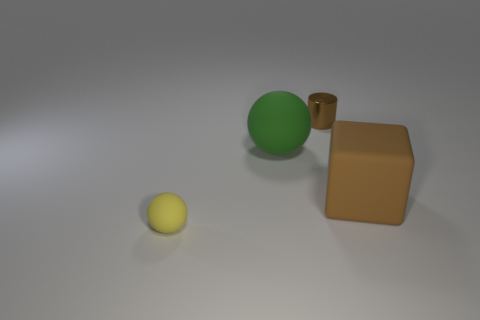Add 4 tiny purple things. How many objects exist? 8 Subtract all cubes. How many objects are left? 3 Subtract all brown shiny things. Subtract all big things. How many objects are left? 1 Add 1 small brown metal objects. How many small brown metal objects are left? 2 Add 3 matte objects. How many matte objects exist? 6 Subtract 1 green balls. How many objects are left? 3 